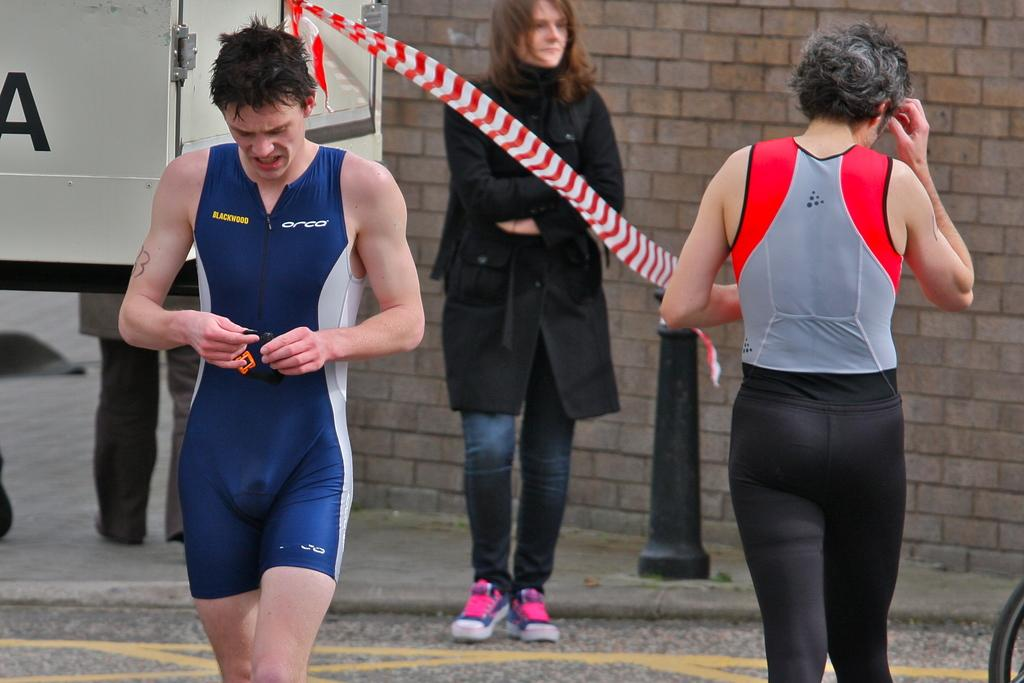<image>
Write a terse but informative summary of the picture. A man in a blue jumper with Blackwood on the chest 